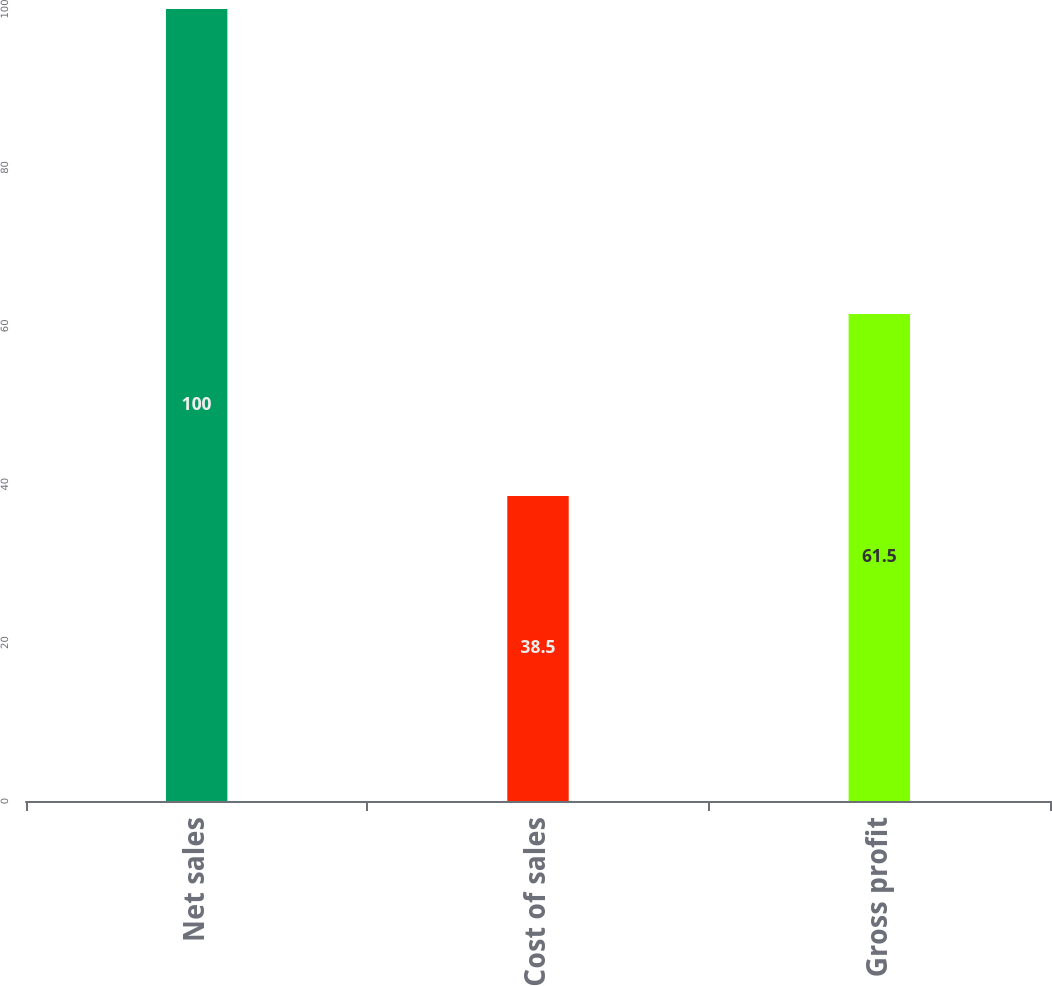Convert chart. <chart><loc_0><loc_0><loc_500><loc_500><bar_chart><fcel>Net sales<fcel>Cost of sales<fcel>Gross profit<nl><fcel>100<fcel>38.5<fcel>61.5<nl></chart> 